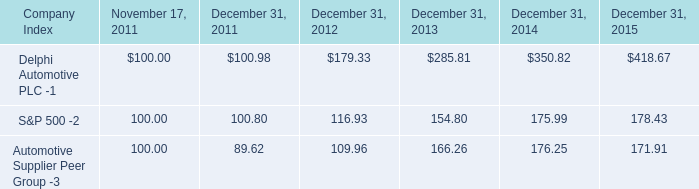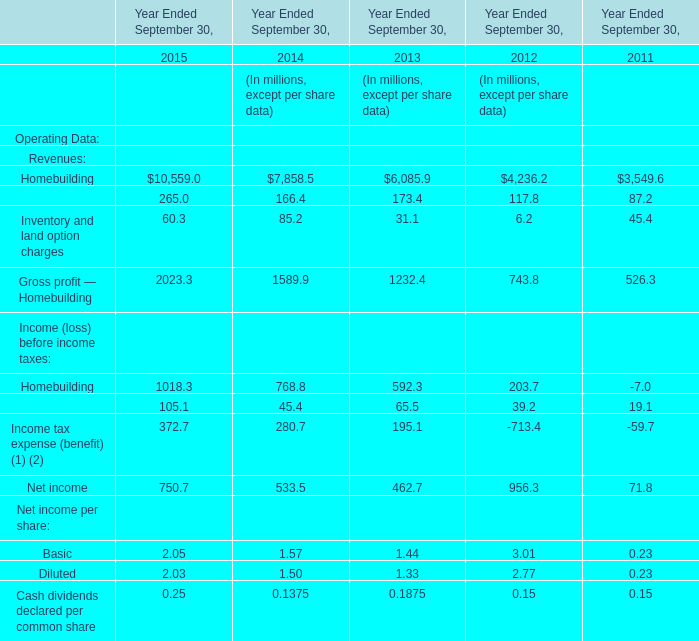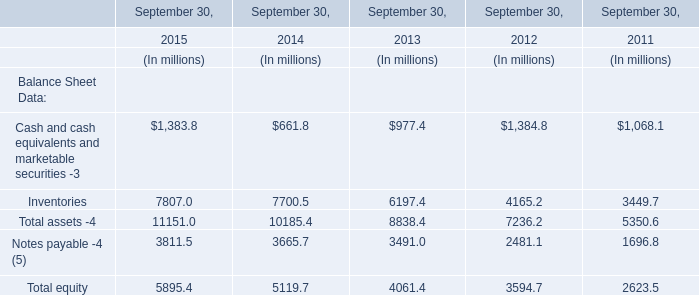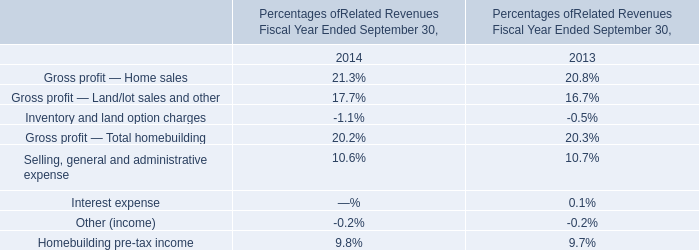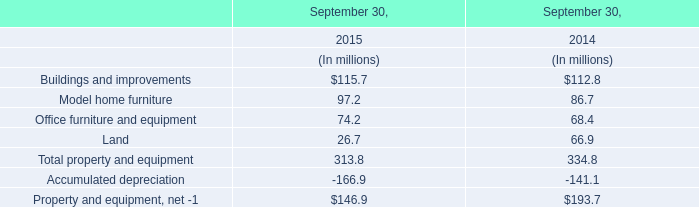In which year the Homebuilding of Revenues is positive? 
Answer: 2015. 